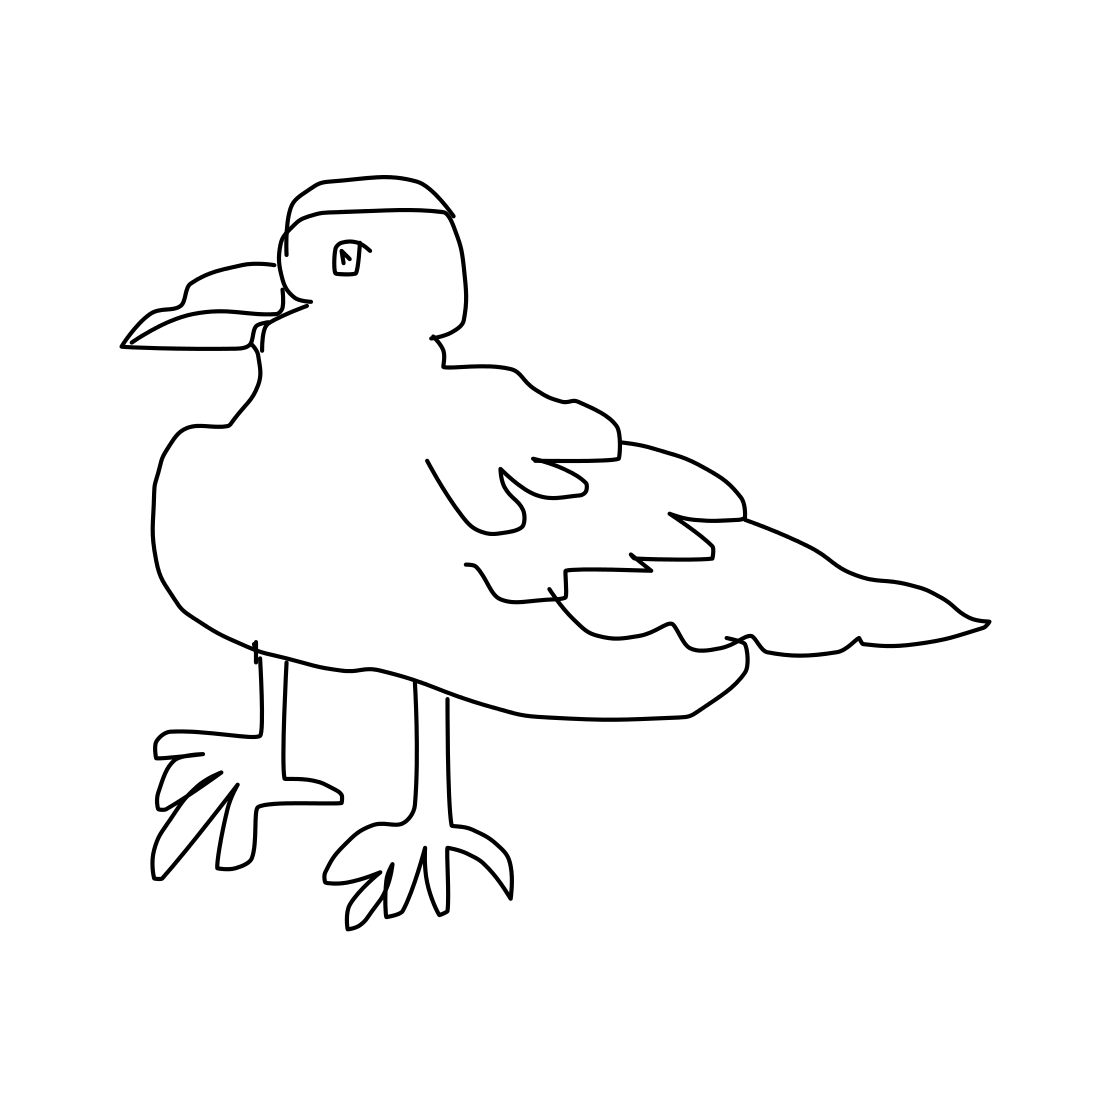Can you describe what you see in the image? The image displays a black and white line drawing of a bird, likely a seabird, characterized by its broad wings, webbed feet, and a prominent beak. The simplicity of the drawing emphasizes the bird's distinct features. 